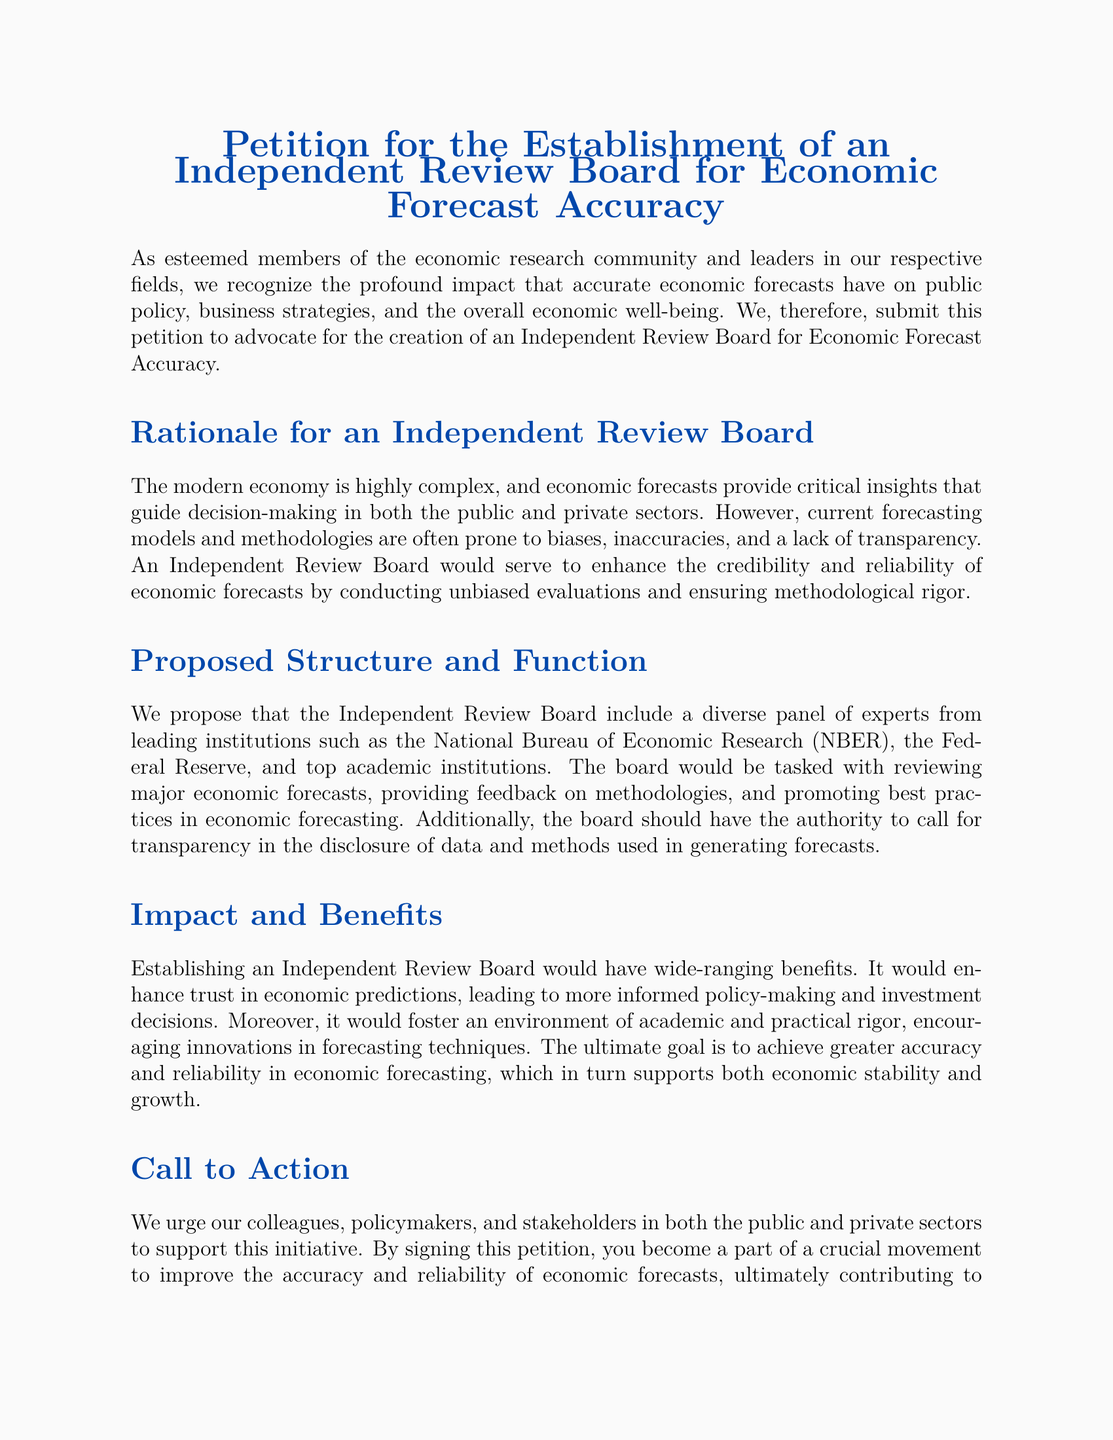What is the title of the petition? The title of the petition is at the beginning of the document and clearly states the purpose of the petition.
Answer: Petition for the Establishment of an Independent Review Board for Economic Forecast Accuracy Who signed the petition? The signatures are listed at the end of the document, providing the names and titles of the signatories.
Answer: Dr. Jane Doe, Prof. John Smith, Dr. Emily White What is the main goal of the proposed Independent Review Board? The document outlines that the main goal of the Independent Review Board is to enhance economic forecast accuracy.
Answer: Enhance economic forecast accuracy Which institutions are suggested to provide experts for the board? The document mentions specific institutions that should contribute experts to the review board.
Answer: National Bureau of Economic Research, Federal Reserve, top academic institutions What are the anticipated benefits of establishing the board? The petition outlines several benefits, highlighting the positive changes expected from the board's establishment.
Answer: Enhance trust in economic predictions What is the structure of the proposed board? The document describes the board as including a diverse panel of experts.
Answer: Diverse panel of experts What type of evaluations will the board conduct? The document specifies that the board will conduct unbiased evaluations of economic forecasts.
Answer: Unbiased evaluations What does the petition urge stakeholders to do? The call to action in the petition encourages stakeholders to support the initiative by signing the petition.
Answer: Support this initiative What is the ultimate aim mentioned in the petition? The document clearly states the ultimate aim related to the accuracy and reliability of economic forecasting.
Answer: Greater accuracy and reliability in economic forecasting 